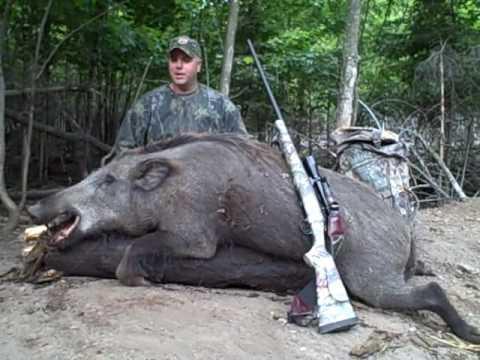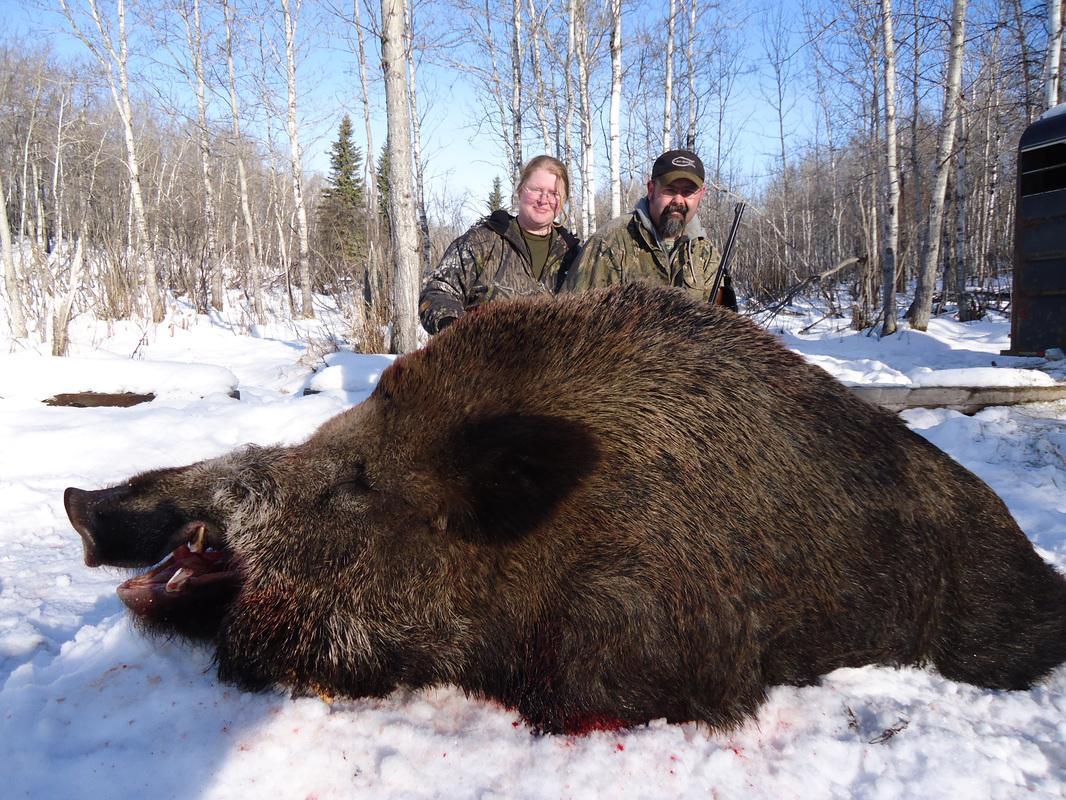The first image is the image on the left, the second image is the image on the right. For the images shown, is this caption "There is at least one hunter with their gun standing next to a dead boar." true? Answer yes or no. Yes. 